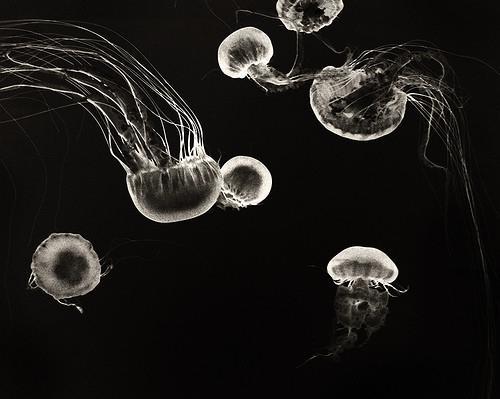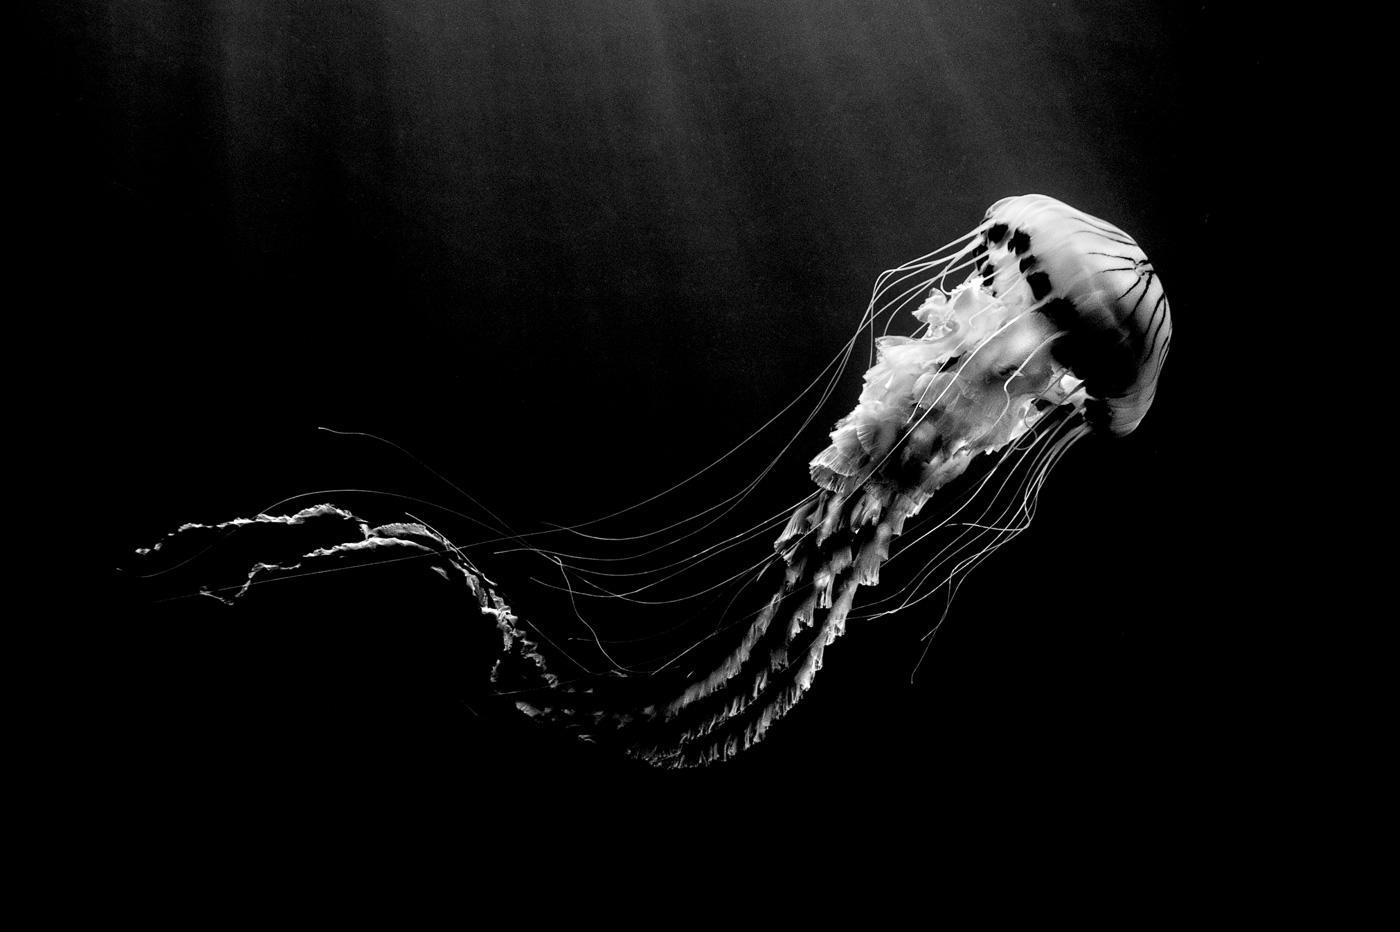The first image is the image on the left, the second image is the image on the right. Examine the images to the left and right. Is the description "The image on the right shows only a single jellyfish swimming to the right." accurate? Answer yes or no. Yes. The first image is the image on the left, the second image is the image on the right. Given the left and right images, does the statement "The combined images total no more than three jellyfish, the left shown on black and the right - shown on a lighter background - featuring a dome-topped jellyfish." hold true? Answer yes or no. No. 